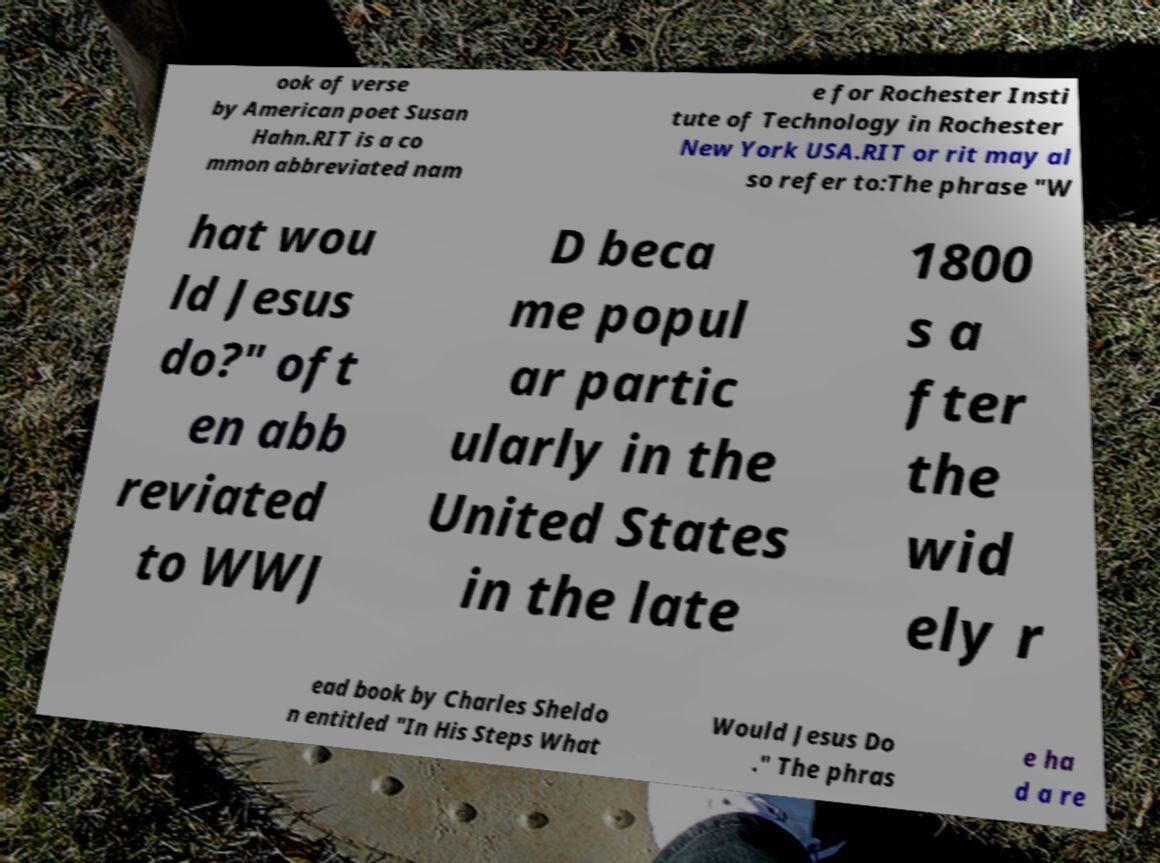Please identify and transcribe the text found in this image. ook of verse by American poet Susan Hahn.RIT is a co mmon abbreviated nam e for Rochester Insti tute of Technology in Rochester New York USA.RIT or rit may al so refer to:The phrase "W hat wou ld Jesus do?" oft en abb reviated to WWJ D beca me popul ar partic ularly in the United States in the late 1800 s a fter the wid ely r ead book by Charles Sheldo n entitled "In His Steps What Would Jesus Do ." The phras e ha d a re 